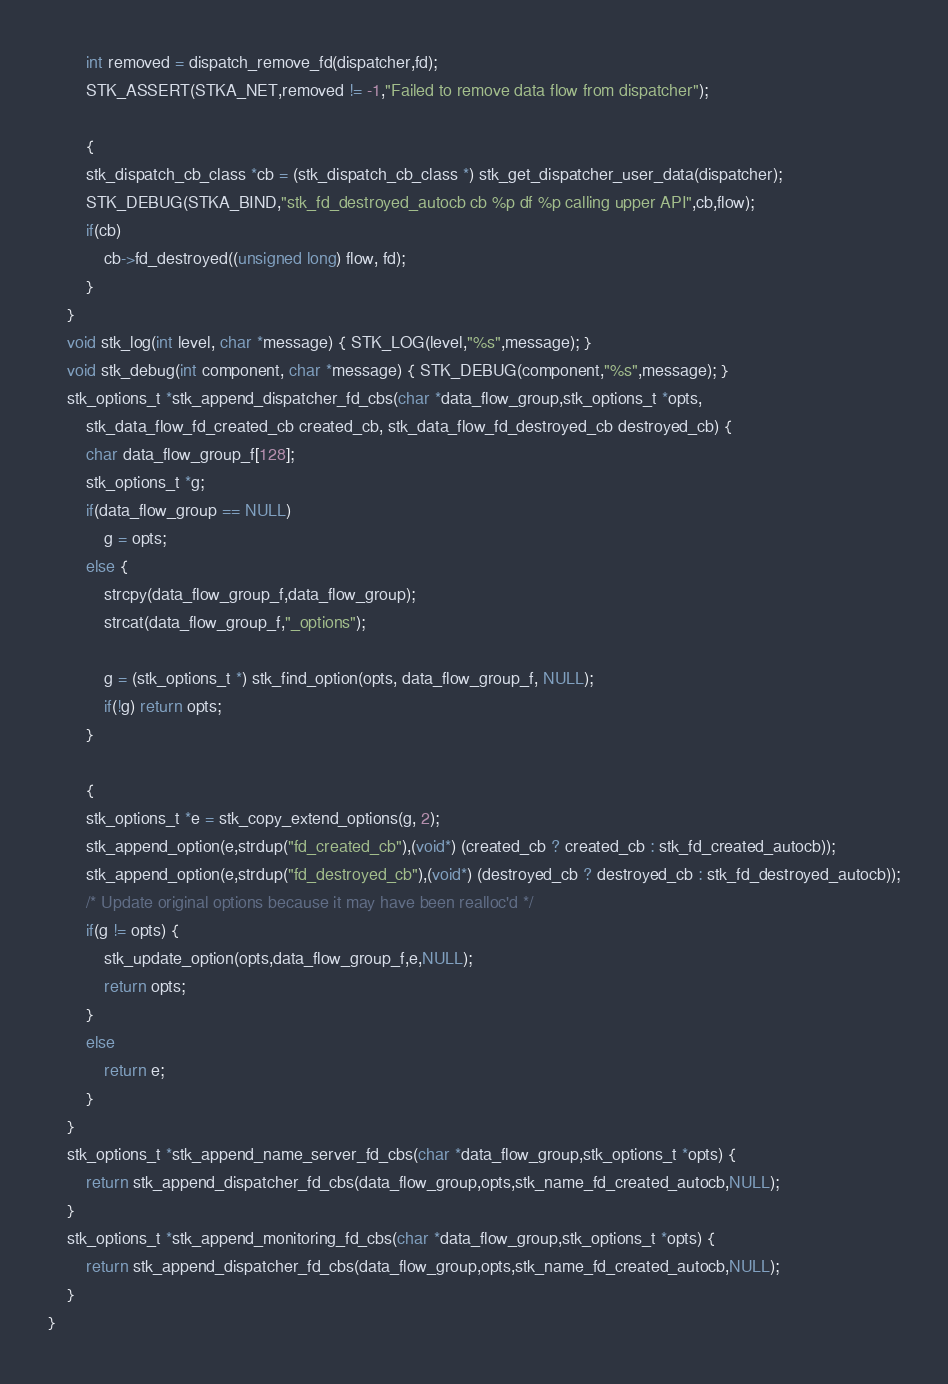Convert code to text. <code><loc_0><loc_0><loc_500><loc_500><_C_>		int removed = dispatch_remove_fd(dispatcher,fd);
		STK_ASSERT(STKA_NET,removed != -1,"Failed to remove data flow from dispatcher");

		{
		stk_dispatch_cb_class *cb = (stk_dispatch_cb_class *) stk_get_dispatcher_user_data(dispatcher);
		STK_DEBUG(STKA_BIND,"stk_fd_destroyed_autocb cb %p df %p calling upper API",cb,flow);
		if(cb)
			cb->fd_destroyed((unsigned long) flow, fd);
		}
	}
	void stk_log(int level, char *message) { STK_LOG(level,"%s",message); }
	void stk_debug(int component, char *message) { STK_DEBUG(component,"%s",message); }
	stk_options_t *stk_append_dispatcher_fd_cbs(char *data_flow_group,stk_options_t *opts,
		stk_data_flow_fd_created_cb created_cb, stk_data_flow_fd_destroyed_cb destroyed_cb) {
		char data_flow_group_f[128];
		stk_options_t *g;
		if(data_flow_group == NULL)
			g = opts;
		else {
			strcpy(data_flow_group_f,data_flow_group);
			strcat(data_flow_group_f,"_options");

			g = (stk_options_t *) stk_find_option(opts, data_flow_group_f, NULL);
			if(!g) return opts;
		}

		{
		stk_options_t *e = stk_copy_extend_options(g, 2);
		stk_append_option(e,strdup("fd_created_cb"),(void*) (created_cb ? created_cb : stk_fd_created_autocb));
		stk_append_option(e,strdup("fd_destroyed_cb"),(void*) (destroyed_cb ? destroyed_cb : stk_fd_destroyed_autocb));
		/* Update original options because it may have been realloc'd */
		if(g != opts) {
			stk_update_option(opts,data_flow_group_f,e,NULL);
			return opts;
		}
		else
			return e;
		}
	}
	stk_options_t *stk_append_name_server_fd_cbs(char *data_flow_group,stk_options_t *opts) {
		return stk_append_dispatcher_fd_cbs(data_flow_group,opts,stk_name_fd_created_autocb,NULL);
	}
	stk_options_t *stk_append_monitoring_fd_cbs(char *data_flow_group,stk_options_t *opts) {
		return stk_append_dispatcher_fd_cbs(data_flow_group,opts,stk_name_fd_created_autocb,NULL);
	}
}
</code> 